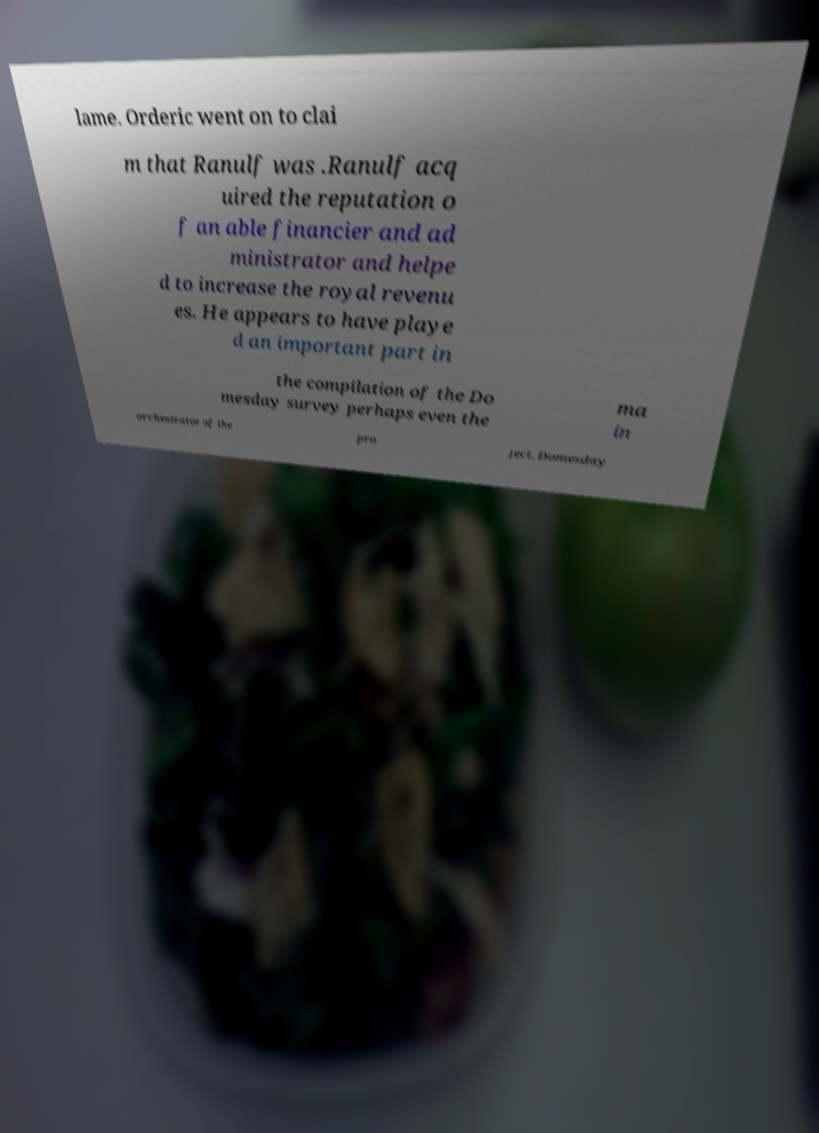Could you extract and type out the text from this image? lame. Orderic went on to clai m that Ranulf was .Ranulf acq uired the reputation o f an able financier and ad ministrator and helpe d to increase the royal revenu es. He appears to have playe d an important part in the compilation of the Do mesday survey perhaps even the ma in orchestrator of the pro ject. Domesday 